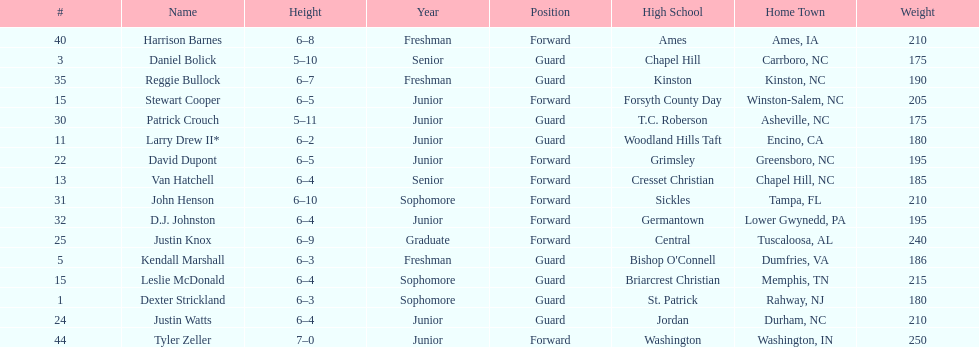How many players are not a junior? 9. 